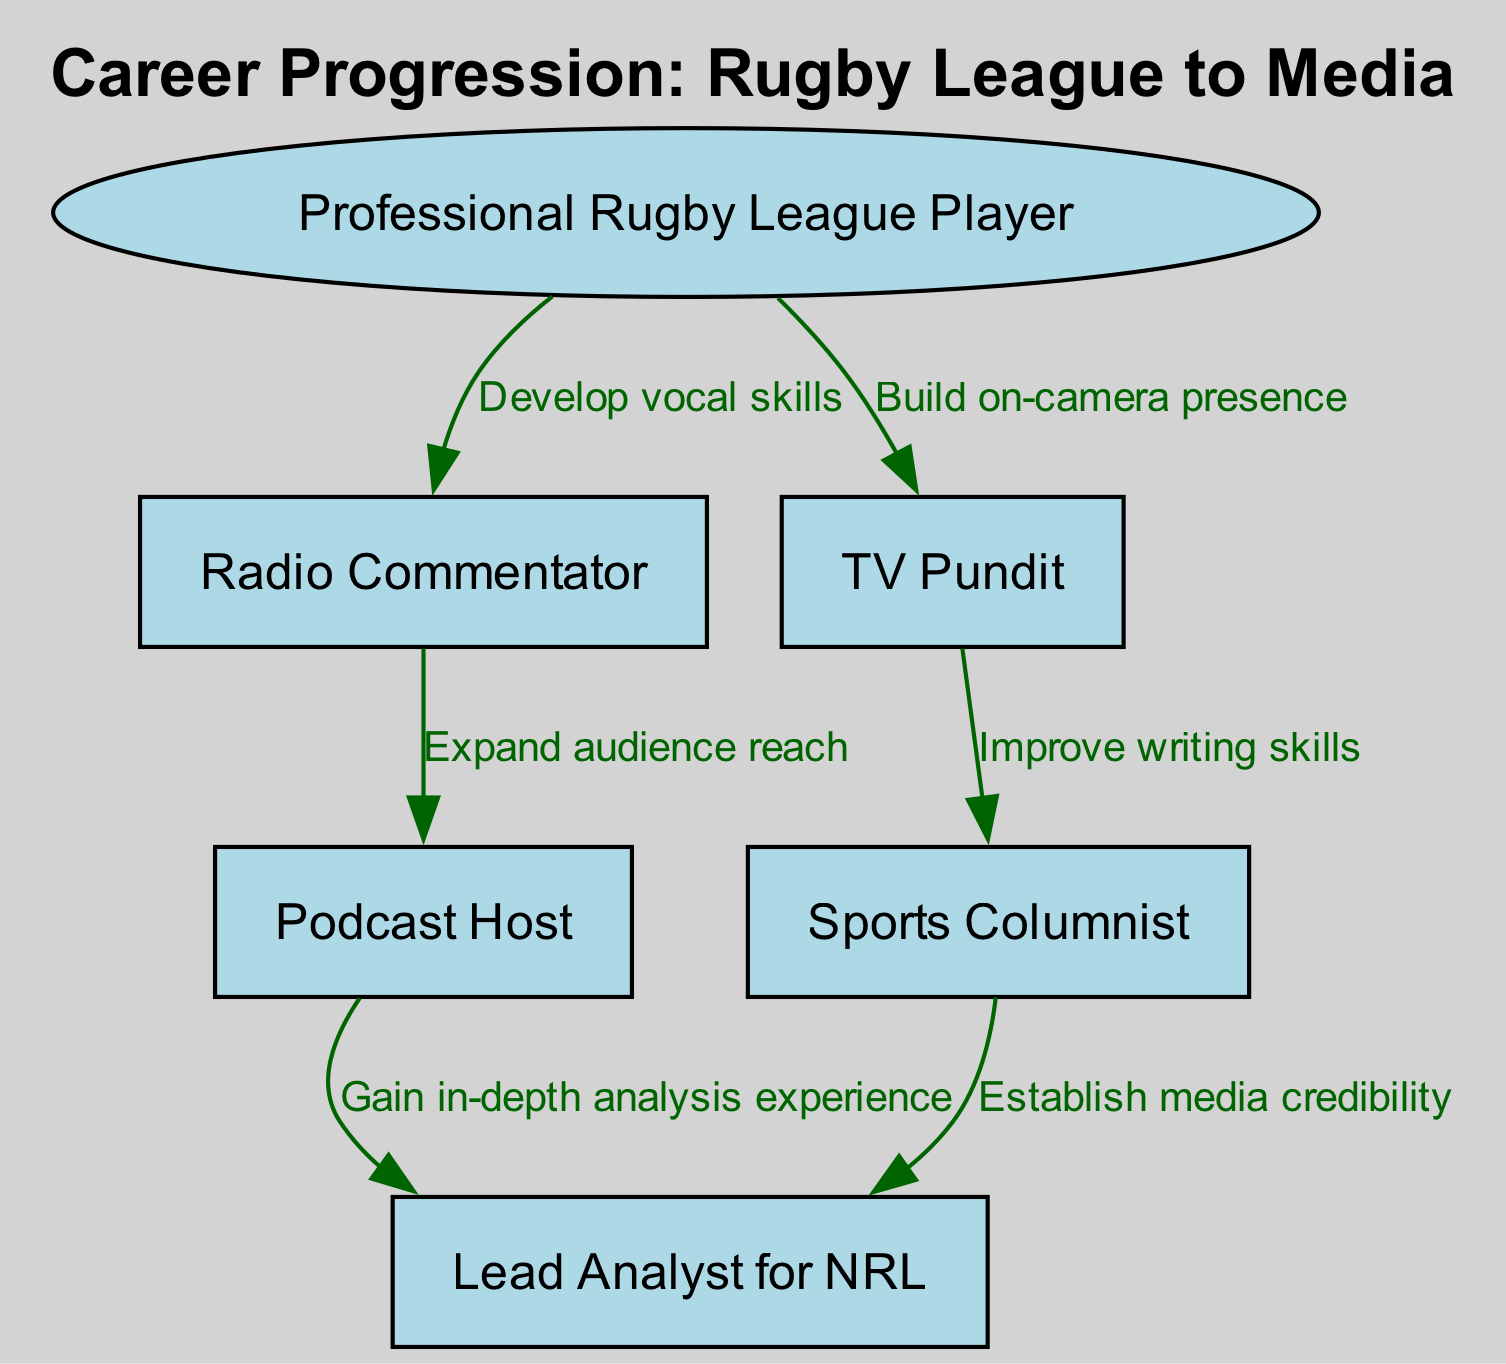What is the starting role for a player transitioning into media? The diagram indicates that the starting role is "Professional Rugby League Player," as it is the first node in the flowchart.
Answer: Professional Rugby League Player How many nodes are present in the diagram? By counting the nodes listed in the data, there are a total of 6 nodes.
Answer: 6 What skill is developed to transition from a Professional Rugby League Player to a Radio Commentator? The edge leading from "Professional Rugby League Player" to "Radio Commentator" states "Develop vocal skills," indicating this necessary skill for the transition.
Answer: Develop vocal skills Which role requires an improvement in writing skills? The connection from "TV Pundit" to "Sports Columnist" specifies "Improve writing skills," indicating that this role focuses on enhancing writing abilities.
Answer: Sports Columnist What role comes after Podcast Host in the progression? Examining the flow from "Podcast Host," the next role it connects to is "Lead Analyst for NRL," marking the progression in the diagram.
Answer: Lead Analyst for NRL Which connection focuses on gaining experience for in-depth analysis? The transition from "Podcast Host" to "Lead Analyst for NRL" highlights the objective as "Gain in-depth analysis experience," showcasing the skill set developed in that connection.
Answer: Gain in-depth analysis experience How does one transition from Radio Commentator to Podcast Host? The edge connecting "Radio Commentator" to "Podcast Host" is described as "Expand audience reach," indicating the focus of the transition process.
Answer: Expand audience reach Which roles are indicated as advanced positions after TV Pundit according to the chart? Following "TV Pundit," the possible paths include "Sports Columnist" and "Lead Analyst for NRL," showing the advanced roles that can be pursued next.
Answer: Sports Columnist, Lead Analyst for NRL What is an essential skill to transition from Sports Columnist to Lead Analyst for NRL? The directed edge from "Sports Columnist" to "Lead Analyst for NRL" states "Establish media credibility," implying this is a crucial skill for that transition.
Answer: Establish media credibility 